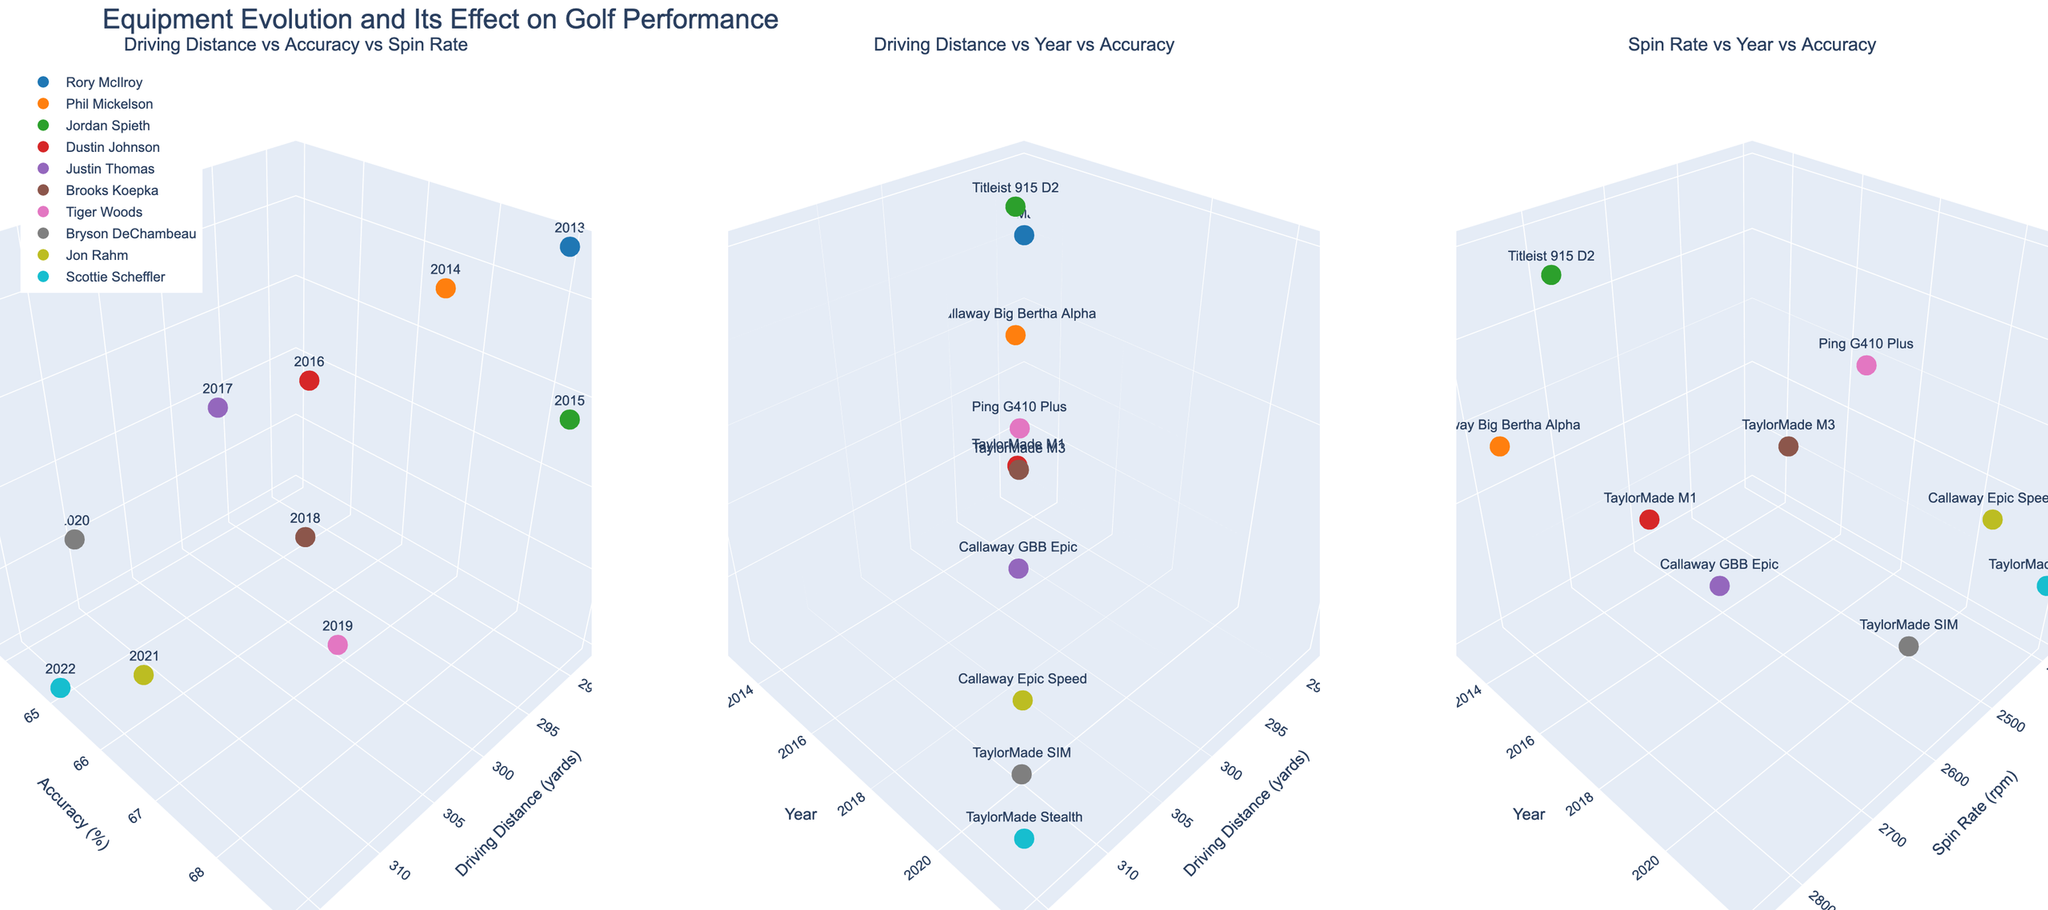What does the title of the plot indicate about the data being visualized? The title "Equipment Evolution and Its Effect on Golf Performance" indicates that the plot explores how the evolution of golf equipment impacts driving distance, accuracy, and spin rate over the years.
Answer: Equipment Evolution and Its Effect on Golf Performance Which player has the highest driving distance and what year is it associated with? Observing the "Driving Distance vs Year vs Accuracy" subplot, Bryson DeChambeau in 2020 has the highest driving distance of 310 yards.
Answer: Bryson DeChambeau, 2020 How does the spin rate trend from 2013 to 2022 for the players? In the "Spin Rate vs Year vs Accuracy" subplot, the spin rate decreases over the years as newer equipment is introduced. Starting from 2850 rpm in 2013, it drops to 2400 rpm in 2022.
Answer: Decreasing Which player shows the best accuracy and with what club? Referring to the "Driving Distance vs Year vs Accuracy" subplot, Jordan Spieth with Titleist 915 D2 in 2015 shows the best accuracy of 69%.
Answer: Jordan Spieth, Titleist 915 D2 Compare the driving distances of Rory McIlroy and Dustin Johnson. Who has a greater driving distance and by how much? In the "Driving Distance vs Year vs Accuracy" subplot, Dustin Johnson (298 yards) has a greater driving distance compared to Rory McIlroy (288 yards). The difference is 10 yards.
Answer: Dustin Johnson by 10 yards From the "Driving Distance vs Accuracy vs Spin Rate" subplot, which equipment leads to the lowest spin rate and who used it? The equipment leading to the lowest spin rate of 2400 rpm is the TaylorMade Stealth, used by Scottie Scheffler in 2022.
Answer: TaylorMade Stealth, Scottie Scheffler What does the color assignment signify in the plot, and can you identify the color used for Brooks Koepka? Each color represents a different player to distinguish their data easily. Brooks Koepka is represented by a bright green color.
Answer: Distinguishes players, bright green for Brooks Koepka What is the relationship between driving distance and accuracy for Phil Mickelson in 2014? In the "Driving Distance vs Accuracy vs Spin Rate" subplot, Phil Mickelson with Callaway Big Bertha Alpha has a driving distance of 292 yards and an accuracy of 67%.
Answer: 292 yards and 67% accuracy What trend can you observe in driving distances over the years for the players? The "Driving Distance vs Year vs Accuracy" subplot shows an increasing trend in driving distances from 2013 to 2022. Starting around 288 yards in 2013 and increasing to 316 yards in 2022.
Answer: Increasing 